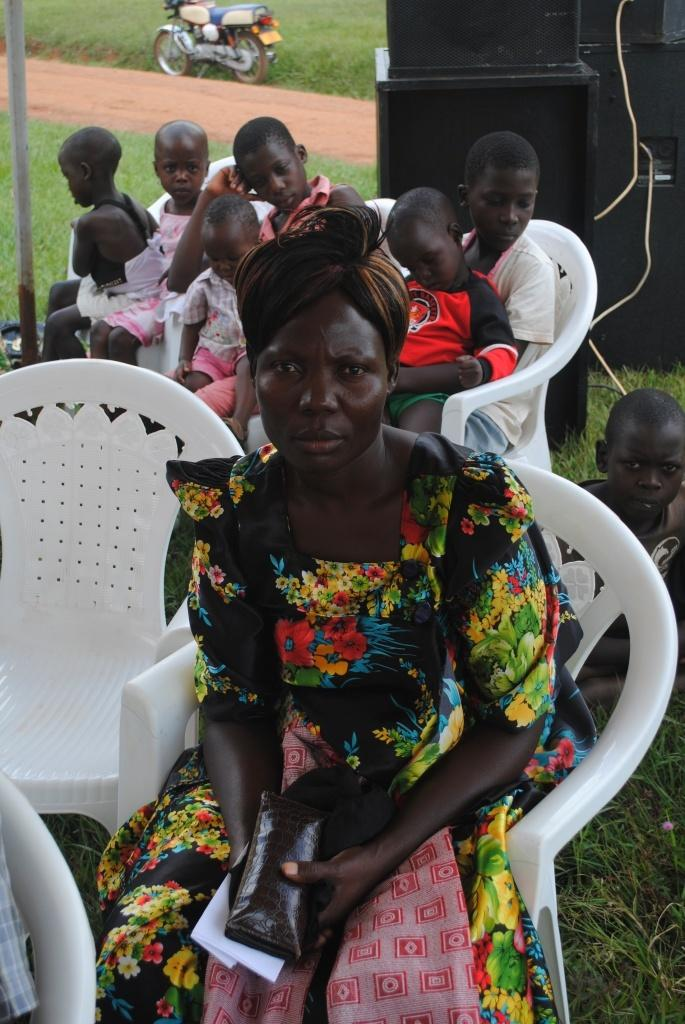What type of furniture is in the image? There are chairs in the image. Who is sitting on the chairs? Children are sitting in the chairs. Can you describe the woman in the image? There is a woman in the image. What can be used for amplifying sound in the image? There are speakers visible in the image. What type of vehicle is present in the image? A wooden bicycle is present in the image. What type of natural environment is visible in the image? Grass is visible in the image. How much money is being exchanged between the children in the image? There is no indication of money or any exchange in the image. What is the range of the speakers in the image? The range of the speakers cannot be determined from the image alone. 